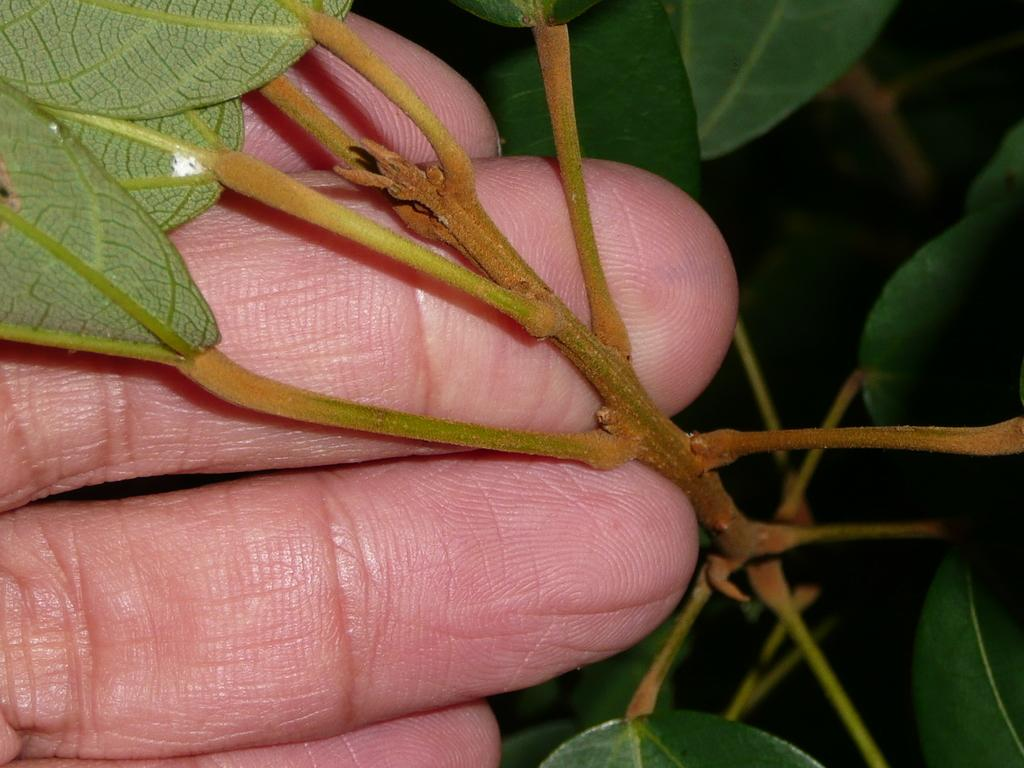What body part is visible in the image? There are fingers visible in the image. What type of plant is shown in the image? There are stems with green leaves in the image. What tax rate is applied to the head in the image? There is no head or tax rate mentioned in the image; it only shows fingers and stems with green leaves. 